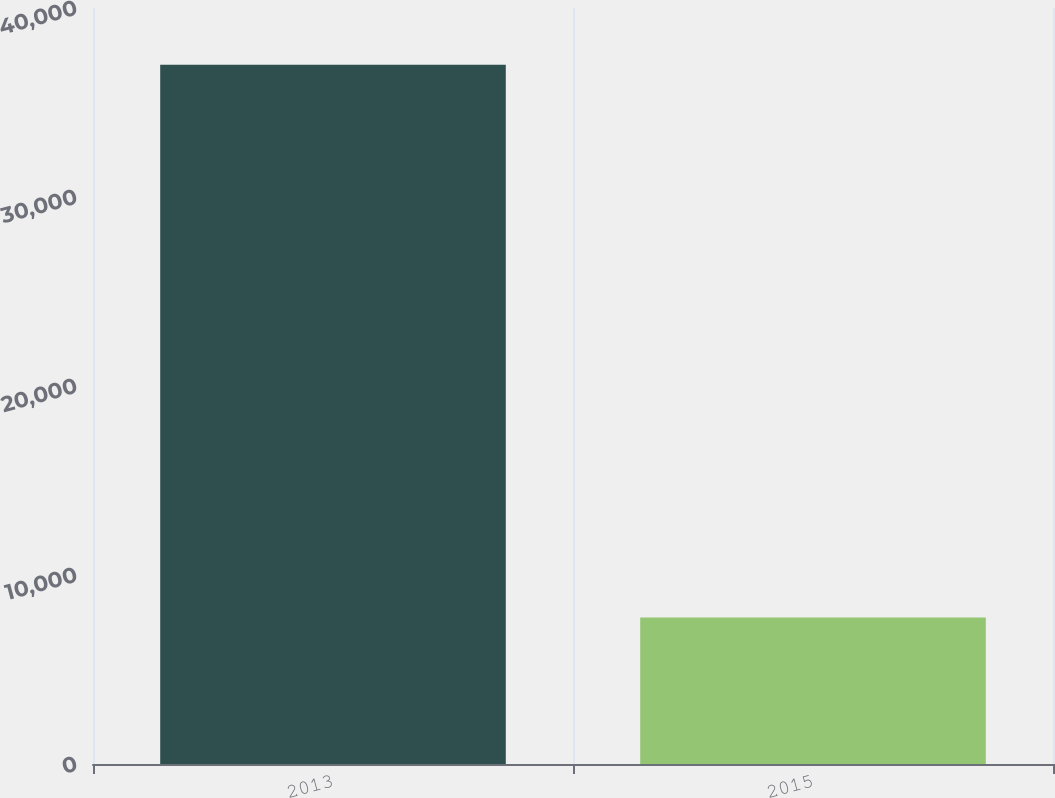Convert chart. <chart><loc_0><loc_0><loc_500><loc_500><bar_chart><fcel>2013<fcel>2015<nl><fcel>36992<fcel>7750<nl></chart> 